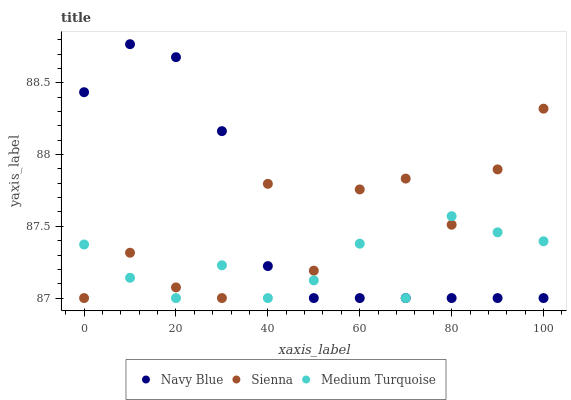Does Medium Turquoise have the minimum area under the curve?
Answer yes or no. Yes. Does Navy Blue have the maximum area under the curve?
Answer yes or no. Yes. Does Navy Blue have the minimum area under the curve?
Answer yes or no. No. Does Medium Turquoise have the maximum area under the curve?
Answer yes or no. No. Is Navy Blue the smoothest?
Answer yes or no. Yes. Is Sienna the roughest?
Answer yes or no. Yes. Is Medium Turquoise the smoothest?
Answer yes or no. No. Is Medium Turquoise the roughest?
Answer yes or no. No. Does Sienna have the lowest value?
Answer yes or no. Yes. Does Navy Blue have the highest value?
Answer yes or no. Yes. Does Medium Turquoise have the highest value?
Answer yes or no. No. Does Sienna intersect Medium Turquoise?
Answer yes or no. Yes. Is Sienna less than Medium Turquoise?
Answer yes or no. No. Is Sienna greater than Medium Turquoise?
Answer yes or no. No. 